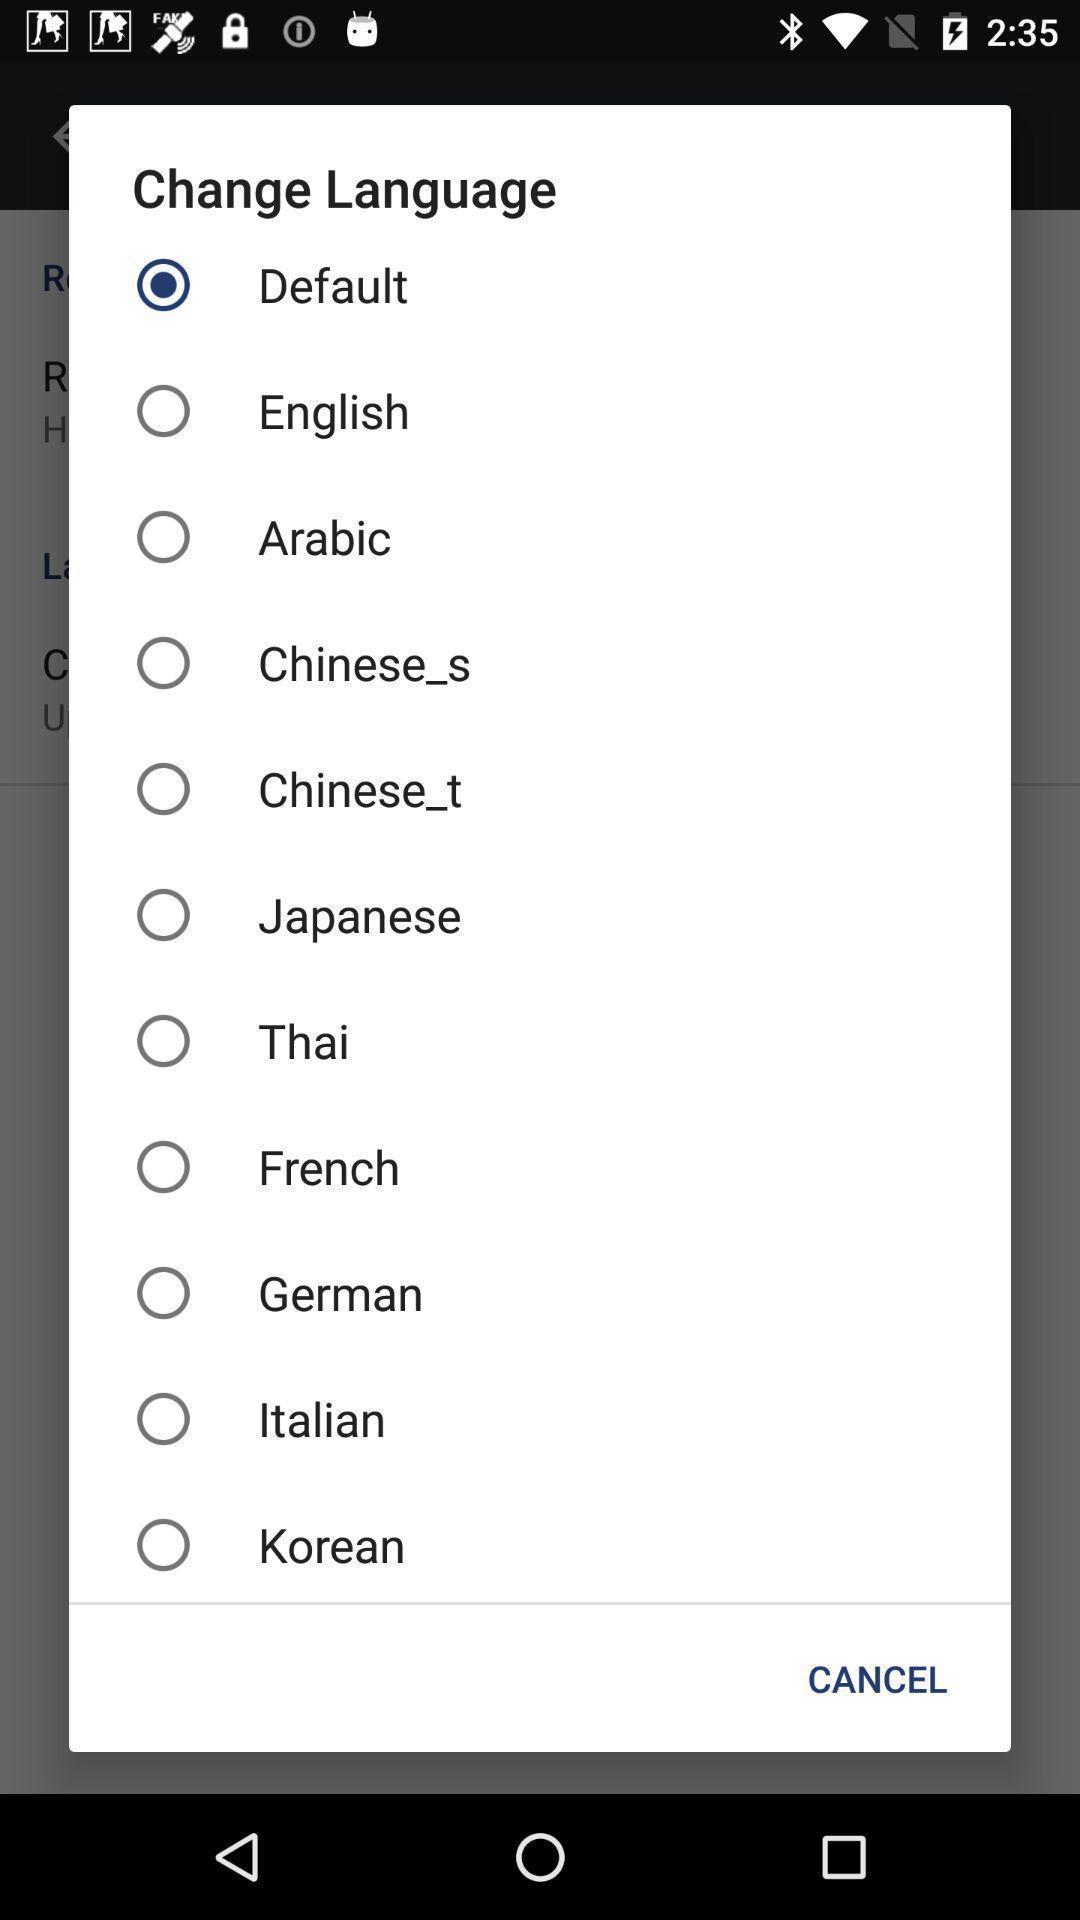Summarize the information in this screenshot. Pop-up list with different language options. 